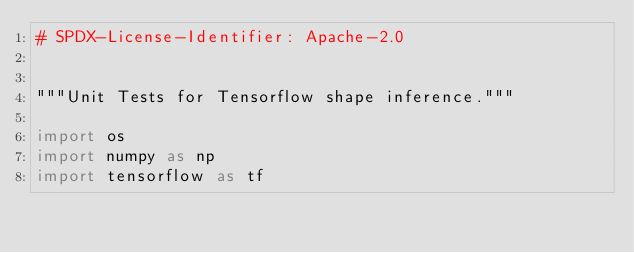Convert code to text. <code><loc_0><loc_0><loc_500><loc_500><_Python_># SPDX-License-Identifier: Apache-2.0


"""Unit Tests for Tensorflow shape inference."""

import os
import numpy as np
import tensorflow as tf
</code> 